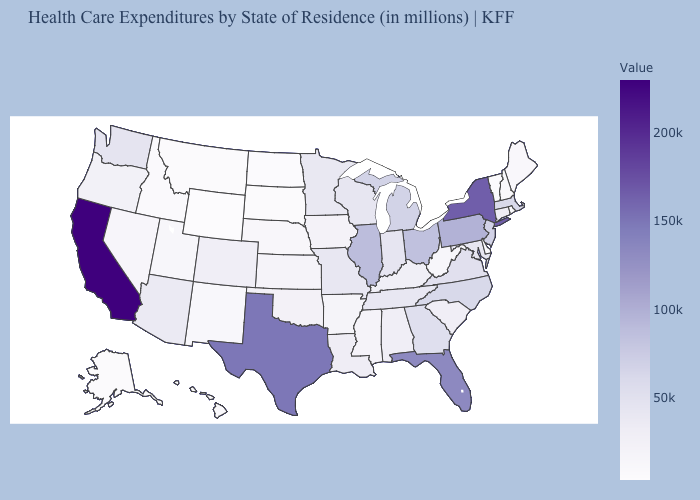Among the states that border West Virginia , does Kentucky have the lowest value?
Give a very brief answer. Yes. Which states have the lowest value in the Northeast?
Short answer required. Vermont. Which states have the lowest value in the MidWest?
Keep it brief. North Dakota. Does the map have missing data?
Give a very brief answer. No. Among the states that border Ohio , does Pennsylvania have the highest value?
Write a very short answer. Yes. Is the legend a continuous bar?
Write a very short answer. Yes. Which states have the lowest value in the USA?
Be succinct. Wyoming. 